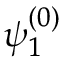<formula> <loc_0><loc_0><loc_500><loc_500>\psi _ { 1 } ^ { ( 0 ) }</formula> 